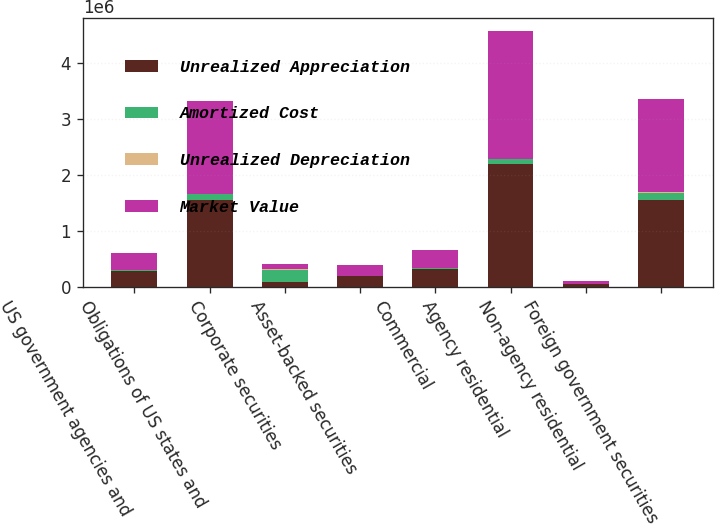Convert chart to OTSL. <chart><loc_0><loc_0><loc_500><loc_500><stacked_bar_chart><ecel><fcel>US government agencies and<fcel>Obligations of US states and<fcel>Corporate securities<fcel>Asset-backed securities<fcel>Commercial<fcel>Agency residential<fcel>Non-agency residential<fcel>Foreign government securities<nl><fcel>Unrealized Appreciation<fcel>284514<fcel>1.55862e+06<fcel>94768.5<fcel>186936<fcel>310387<fcel>2.19894e+06<fcel>53365<fcel>1.55571e+06<nl><fcel>Amortized Cost<fcel>16407<fcel>102815<fcel>197914<fcel>7020<fcel>20942<fcel>86722<fcel>499<fcel>120900<nl><fcel>Unrealized Depreciation<fcel>287<fcel>525<fcel>27054<fcel>550<fcel>9902<fcel>3066<fcel>775<fcel>8389<nl><fcel>Market Value<fcel>300634<fcel>1.6609e+06<fcel>94768.5<fcel>193406<fcel>321427<fcel>2.28259e+06<fcel>53089<fcel>1.66822e+06<nl></chart> 